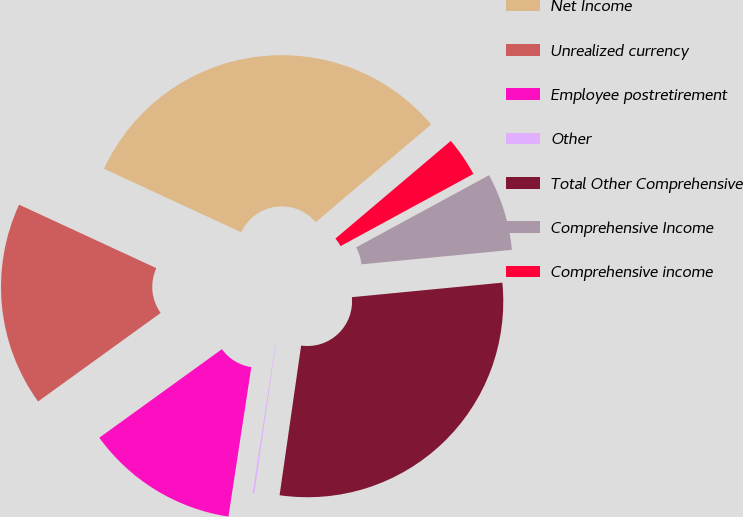<chart> <loc_0><loc_0><loc_500><loc_500><pie_chart><fcel>Net Income<fcel>Unrealized currency<fcel>Employee postretirement<fcel>Other<fcel>Total Other Comprehensive<fcel>Comprehensive Income<fcel>Comprehensive income<nl><fcel>31.93%<fcel>16.85%<fcel>12.63%<fcel>0.14%<fcel>28.81%<fcel>6.39%<fcel>3.26%<nl></chart> 